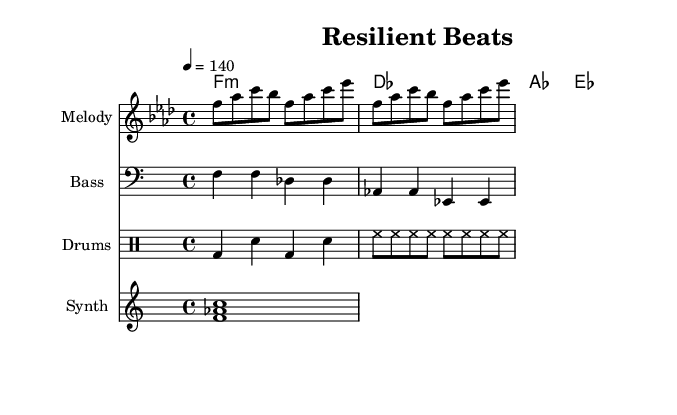What is the key signature of this music? The key signature is indicated by the presence of four flats (B♭, E♭, A♭, and D♭), which is characteristic of F minor.
Answer: F minor What is the tempo marking in this sheet music? The tempo marking is specified at the beginning as "4 = 140," indicating the beats per minute for the quarter note.
Answer: 140 How many measures are present in the melody section? The melody section contains two measures, with the notes grouped accordingly in the provided score.
Answer: 2 What is the time signature for this piece? The time signature is indicated at the beginning of the score, showing that it is in 4/4, meaning there are four beats per measure.
Answer: 4/4 What type of instrument is indicated for the staff labeled "Drums"? The staff labeled "Drums" indicates a drum set, which is a standard designation for the percussion section in this context.
Answer: Drum set Which chord is played at the beginning of the harmony section? The first harmony indicated is an F minor chord, as signified by the first chord in the chord mode notation.
Answer: F minor How many different instrumental parts are included in this score? The score contains four distinct parts: Melody, Bass, Drums, and Synth, indicating a variety of instrumental layers.
Answer: 4 